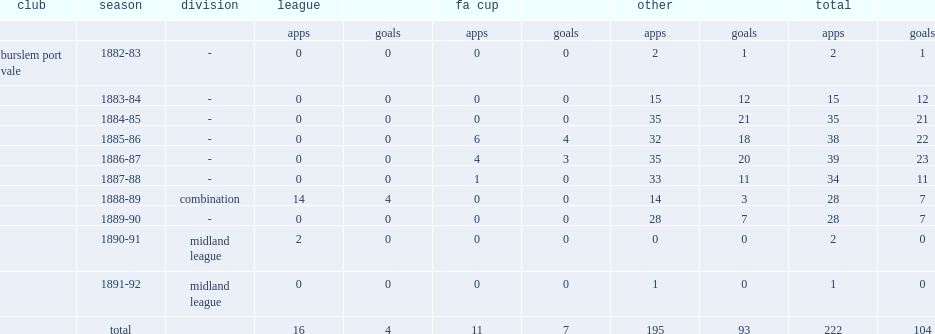How many goals did billy reynolds make in 222 games for the vale? 104.0. 